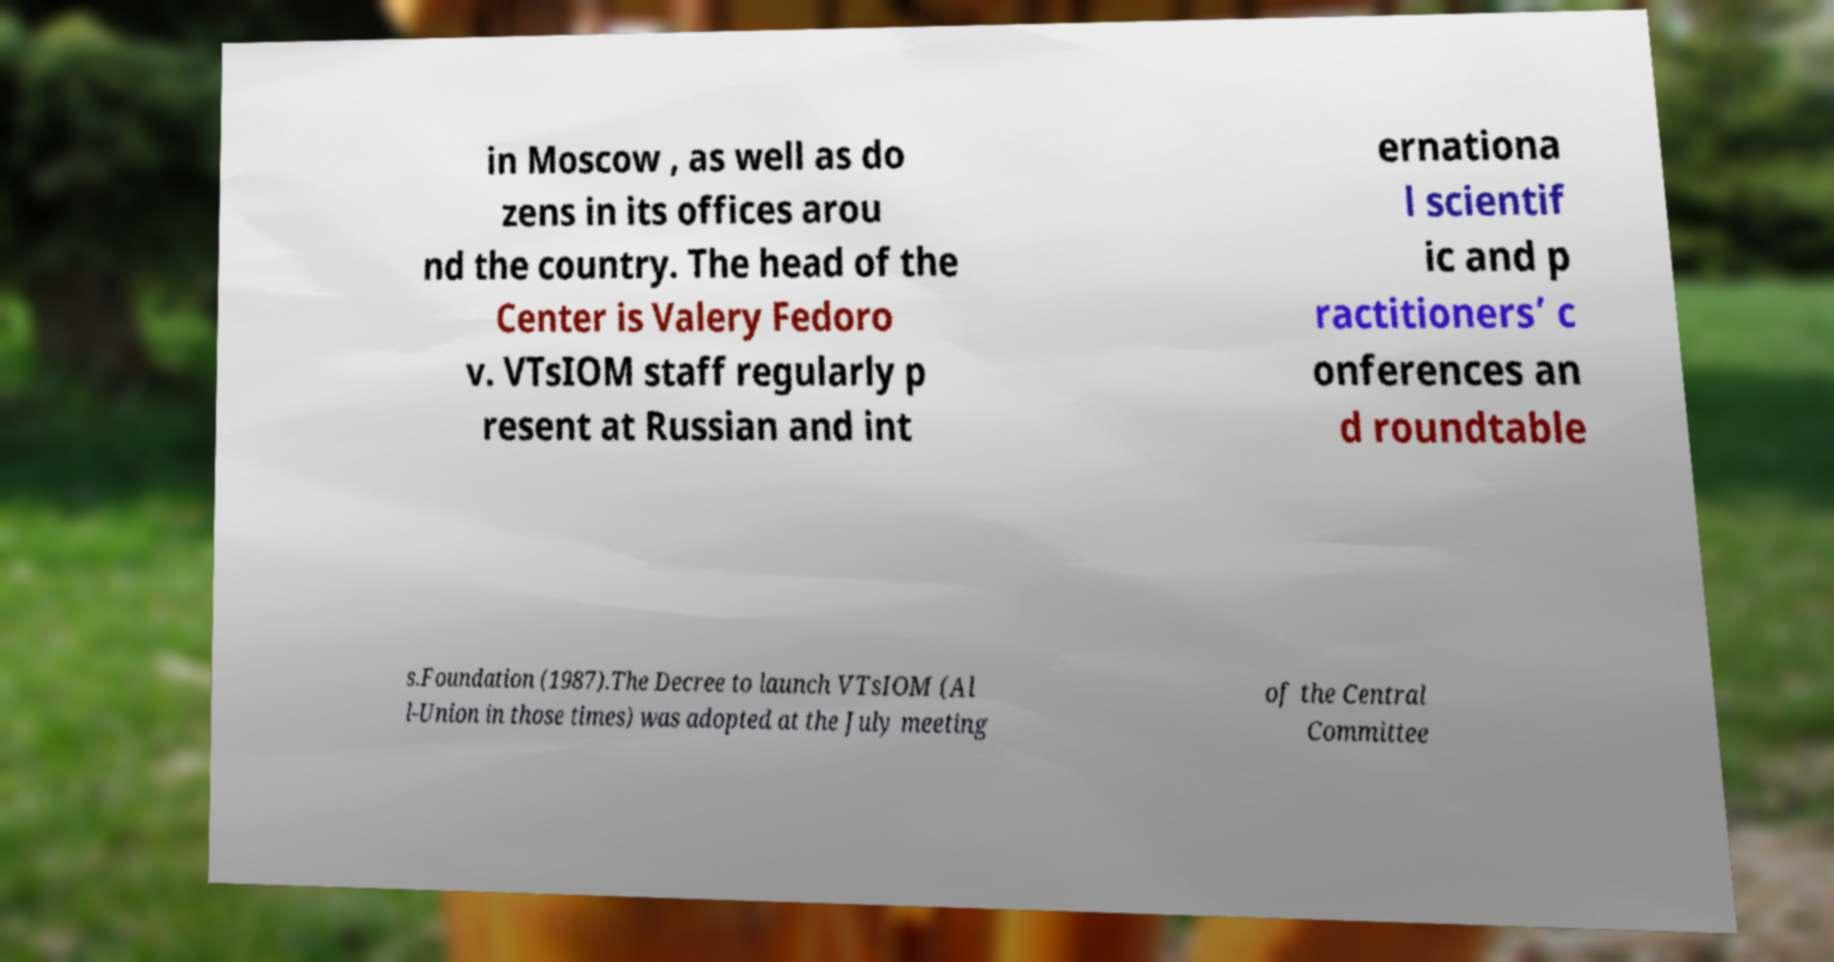What messages or text are displayed in this image? I need them in a readable, typed format. in Moscow , as well as do zens in its offices arou nd the country. The head of the Center is Valery Fedoro v. VTsIOM staff regularly p resent at Russian and int ernationa l scientif ic and p ractitioners’ c onferences an d roundtable s.Foundation (1987).The Decree to launch VTsIOM (Al l-Union in those times) was adopted at the July meeting of the Central Committee 